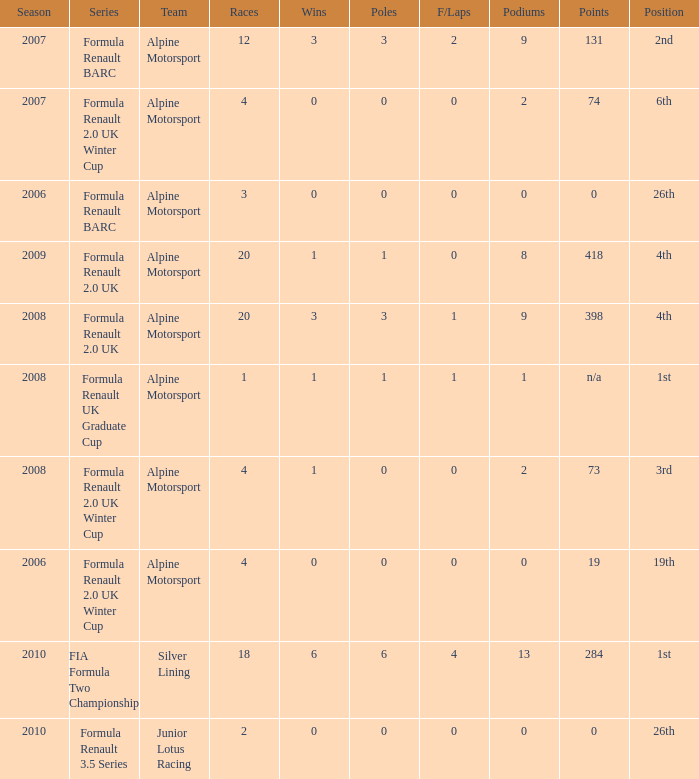What was the earliest season where podium was 9? 2007.0. 